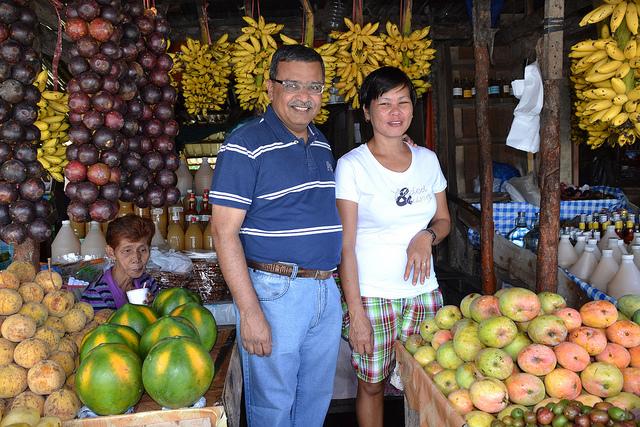Where is this?
Quick response, please. Market. Is the man wearing a belt?
Short answer required. Yes. Are the fruits ripe?
Quick response, please. Yes. 